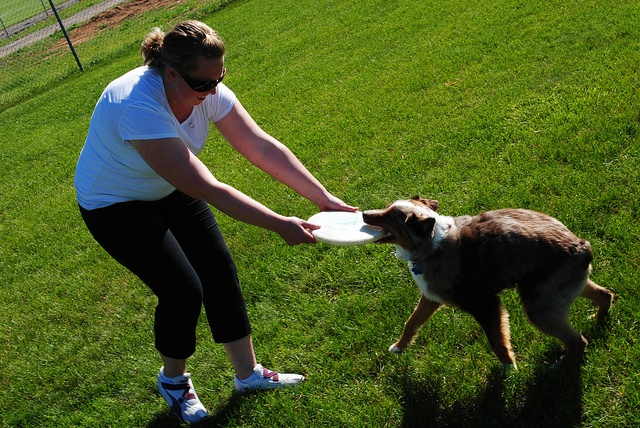Describe the objects in this image and their specific colors. I can see people in olive, black, blue, and gray tones, dog in olive, black, tan, and lightgray tones, and frisbee in olive, white, gray, darkgray, and black tones in this image. 